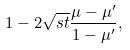Convert formula to latex. <formula><loc_0><loc_0><loc_500><loc_500>1 - 2 \sqrt { s t } \frac { \mu - \mu ^ { \prime } } { 1 - \mu ^ { \prime } } ,</formula> 